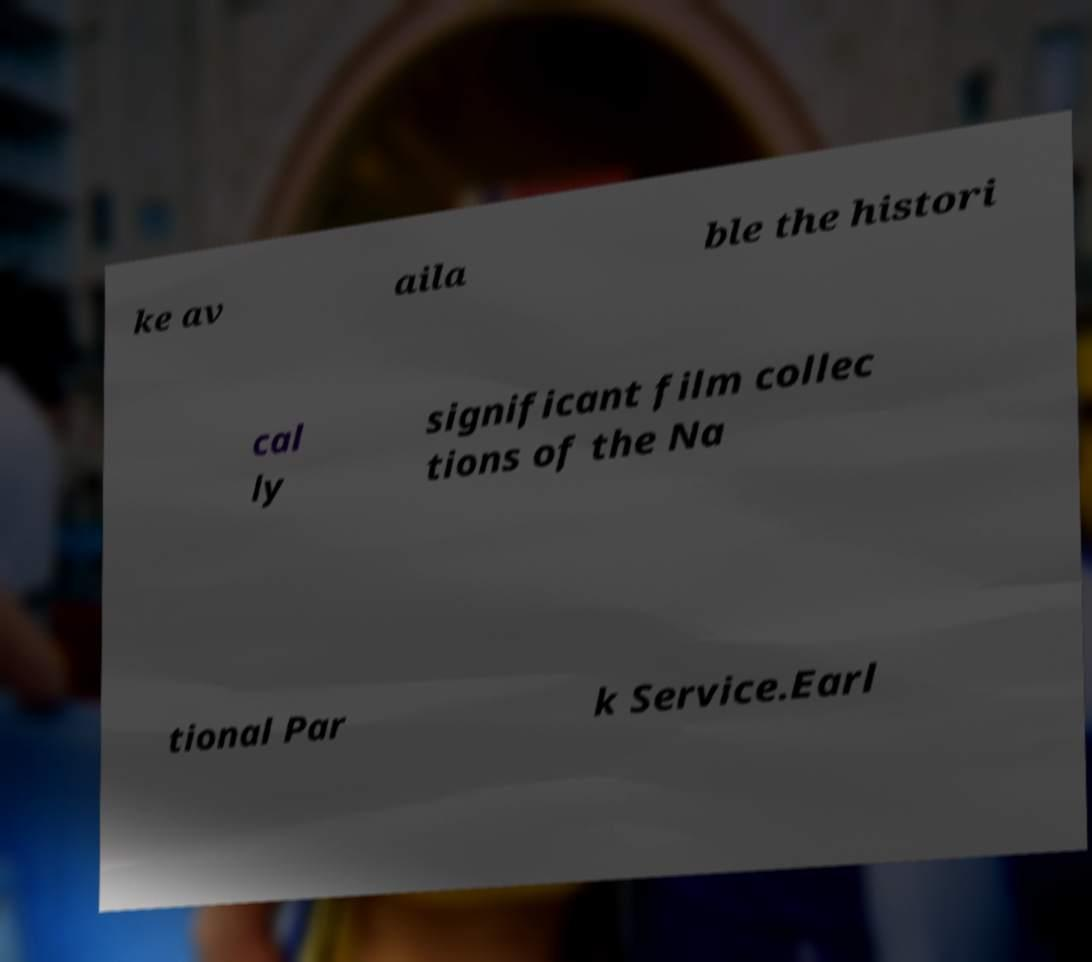Could you assist in decoding the text presented in this image and type it out clearly? ke av aila ble the histori cal ly significant film collec tions of the Na tional Par k Service.Earl 